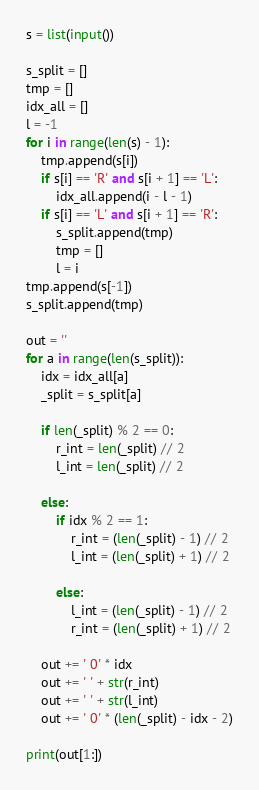<code> <loc_0><loc_0><loc_500><loc_500><_Python_>s = list(input())

s_split = []
tmp = []
idx_all = []
l = -1
for i in range(len(s) - 1):
    tmp.append(s[i])
    if s[i] == 'R' and s[i + 1] == 'L':
        idx_all.append(i - l - 1)
    if s[i] == 'L' and s[i + 1] == 'R':
        s_split.append(tmp)
        tmp = []
        l = i
tmp.append(s[-1])
s_split.append(tmp)

out = ''
for a in range(len(s_split)):
    idx = idx_all[a]
    _split = s_split[a]

    if len(_split) % 2 == 0:
        r_int = len(_split) // 2
        l_int = len(_split) // 2

    else:
        if idx % 2 == 1:
            r_int = (len(_split) - 1) // 2
            l_int = (len(_split) + 1) // 2

        else:
            l_int = (len(_split) - 1) // 2
            r_int = (len(_split) + 1) // 2

    out += ' 0' * idx
    out += ' ' + str(r_int)
    out += ' ' + str(l_int)
    out += ' 0' * (len(_split) - idx - 2)

print(out[1:])
</code> 